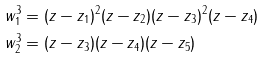Convert formula to latex. <formula><loc_0><loc_0><loc_500><loc_500>w _ { 1 } ^ { 3 } & = ( z - z _ { 1 } ) ^ { 2 } ( z - z _ { 2 } ) ( z - z _ { 3 } ) ^ { 2 } ( z - z _ { 4 } ) \\ w _ { 2 } ^ { 3 } & = ( z - z _ { 3 } ) ( z - z _ { 4 } ) ( z - z _ { 5 } )</formula> 